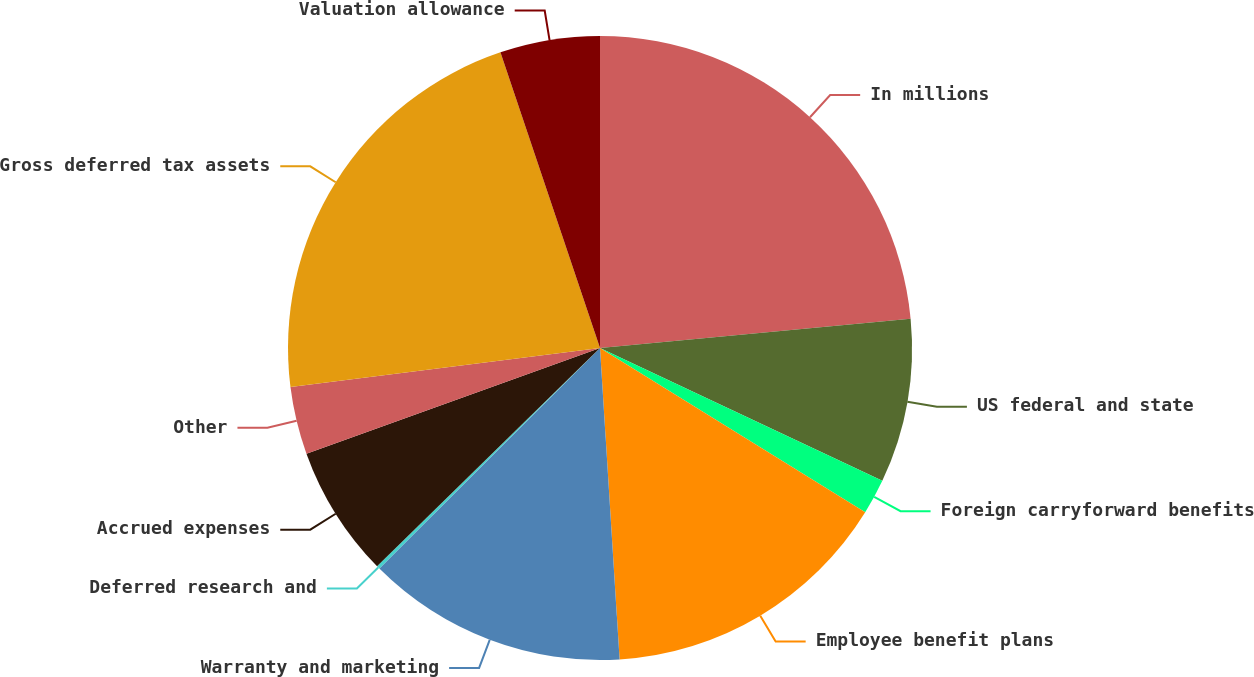<chart> <loc_0><loc_0><loc_500><loc_500><pie_chart><fcel>In millions<fcel>US federal and state<fcel>Foreign carryforward benefits<fcel>Employee benefit plans<fcel>Warranty and marketing<fcel>Deferred research and<fcel>Accrued expenses<fcel>Other<fcel>Gross deferred tax assets<fcel>Valuation allowance<nl><fcel>23.5%<fcel>8.5%<fcel>1.83%<fcel>15.17%<fcel>13.5%<fcel>0.17%<fcel>6.83%<fcel>3.5%<fcel>21.83%<fcel>5.17%<nl></chart> 